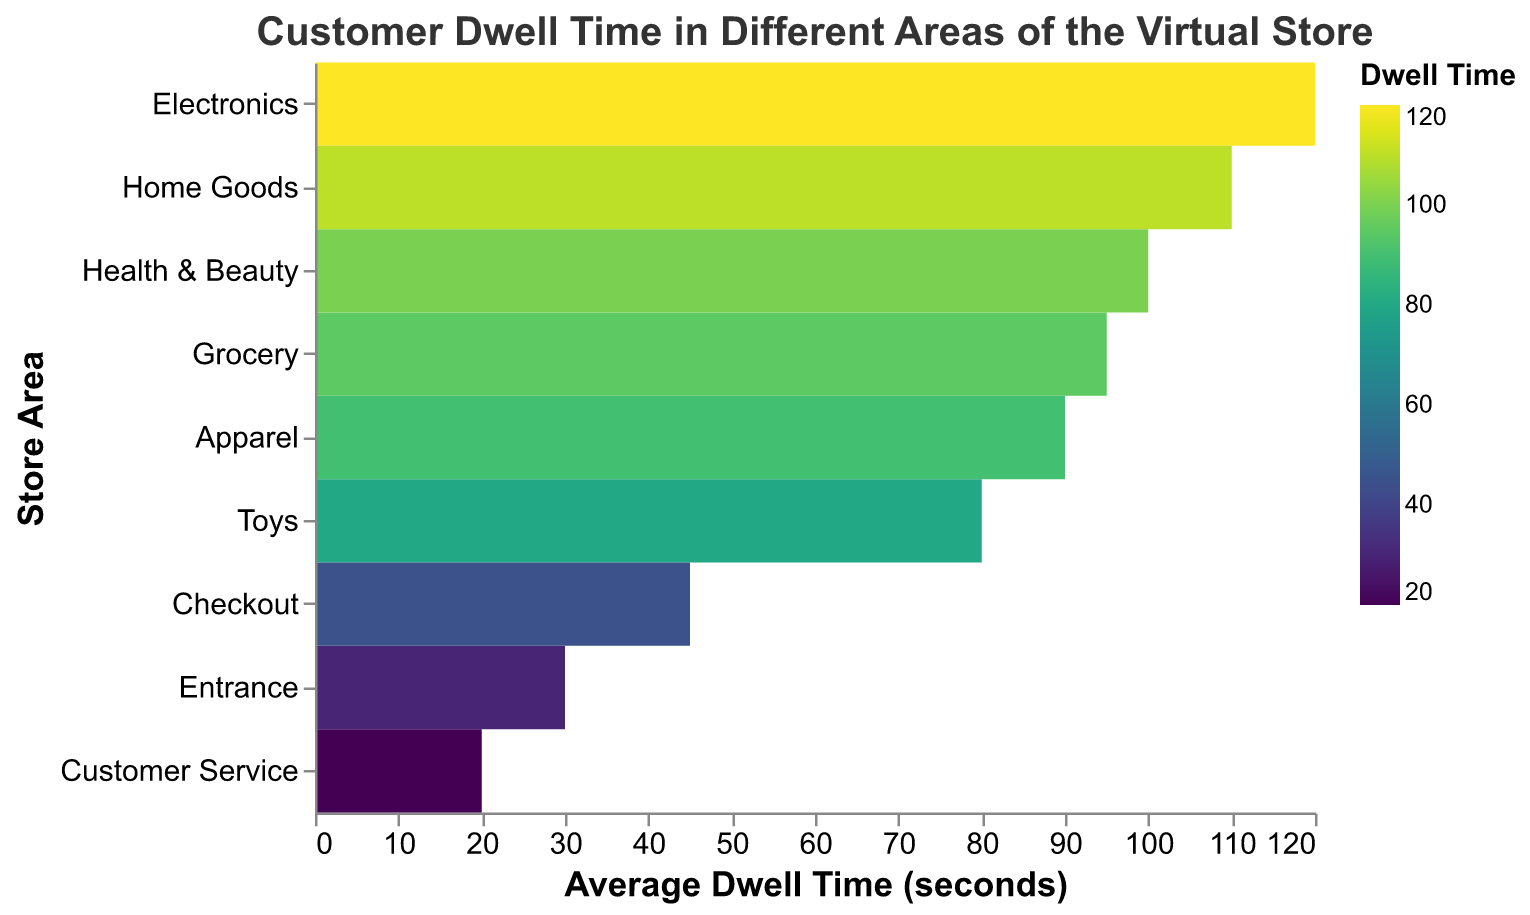What is the area with the highest average dwell time? By observing the heatmap, identify the area with the darkest color, indicating the highest dwell time. In this case, it's the "Electronics."
Answer: Electronics What is the title of the heatmap? The title is located at the top of the figure in large, bold font. It reads "Customer Dwell Time in Different Areas of the Virtual Store."
Answer: Customer Dwell Time in Different Areas of the Virtual Store Which area has the lowest average dwell time? Check the heatmap for the area with the lightest color, indicating the shortest dwell time. This area is the "Customer Service."
Answer: Customer Service What is the average dwell time in the Grocery area? Look at the color legend and trace it to the Grocery row on the heatmap. The corresponding average dwell time is 95 seconds.
Answer: 95 seconds How much more time do customers spend in the Home Goods area compared to the Toys area? Find the dwell times for both areas: Home Goods (110 seconds) and Toys (80 seconds). Subtract the Toys dwell time from the Home Goods dwell time: 110 - 80 = 30.
Answer: 30 seconds What is the average dwell time in the Apparel section? Locate the Apparel section in the heatmap and refer to the average dwell time, which is 90 seconds.
Answer: 90 seconds Which area has a dwell time of 45 seconds? Refer to the heatmap and identify the area with a color that matches 45 seconds from the legend. This area is the "Checkout."
Answer: Checkout How does the average dwell time in Health & Beauty compare with that in Home Goods? Observe their respective average dwell times: Health & Beauty (100 seconds) and Home Goods (110 seconds). Health & Beauty's dwell time is 10 seconds less than Home Goods.
Answer: 10 seconds less What is the combined dwell time for the Electronics and Apparel areas? Sum the average dwell times for Electronics (120 seconds) and Apparel (90 seconds): 120 + 90 = 210 seconds.
Answer: 210 seconds Which area do customers spend more time in: Grocery or Health & Beauty? Compare the average dwell times: Grocery (95 seconds) and Health & Beauty (100 seconds). Customers spend more time in Health & Beauty.
Answer: Health & Beauty 